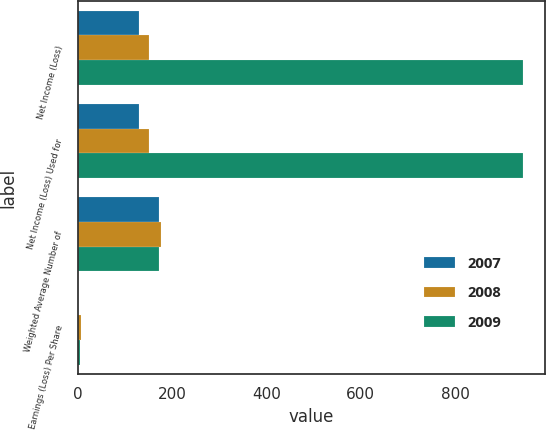Convert chart to OTSL. <chart><loc_0><loc_0><loc_500><loc_500><stacked_bar_chart><ecel><fcel>Net Income (Loss)<fcel>Net Income (Loss) Used for<fcel>Weighted Average Number of<fcel>Earnings (Loss) Per Share<nl><fcel>2007<fcel>131<fcel>131<fcel>173<fcel>0.75<nl><fcel>2008<fcel>151<fcel>151<fcel>176<fcel>7.58<nl><fcel>2009<fcel>944<fcel>944<fcel>173<fcel>5.45<nl></chart> 